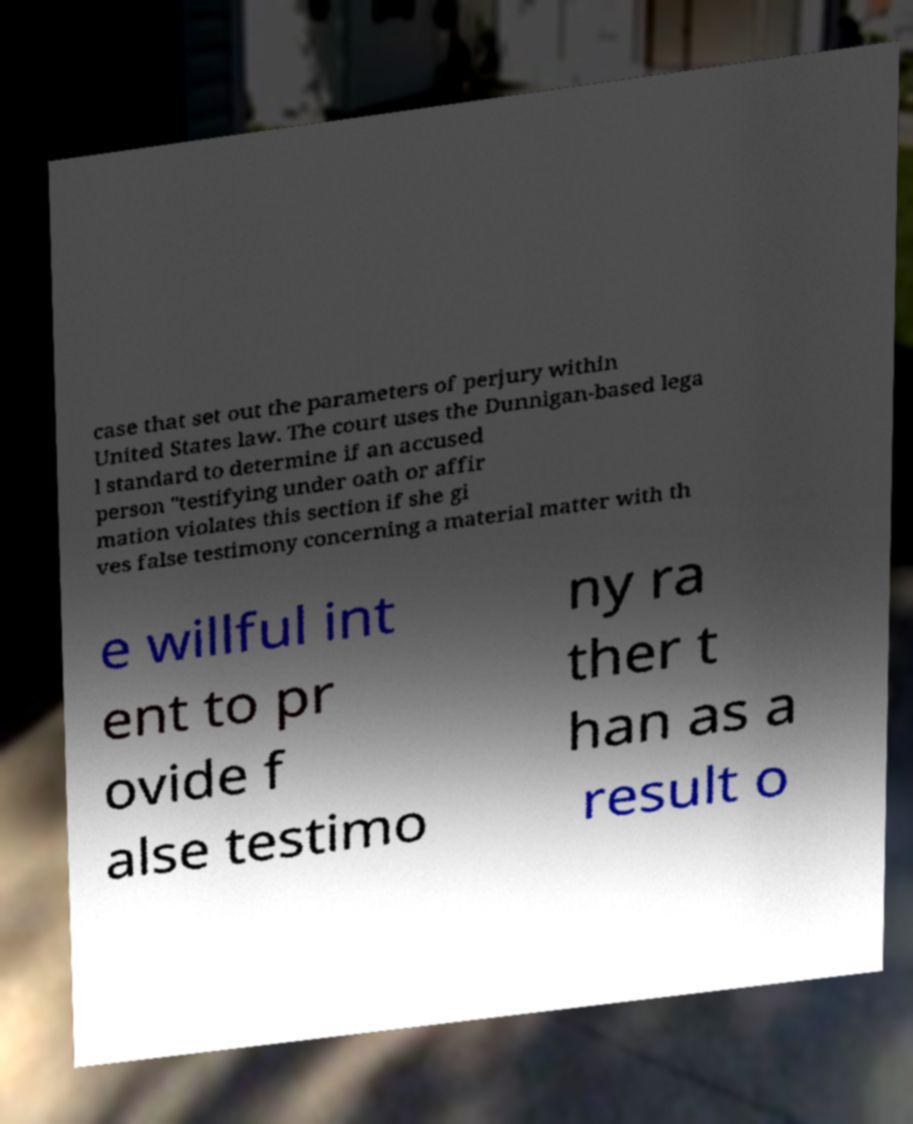What messages or text are displayed in this image? I need them in a readable, typed format. case that set out the parameters of perjury within United States law. The court uses the Dunnigan-based lega l standard to determine if an accused person "testifying under oath or affir mation violates this section if she gi ves false testimony concerning a material matter with th e willful int ent to pr ovide f alse testimo ny ra ther t han as a result o 